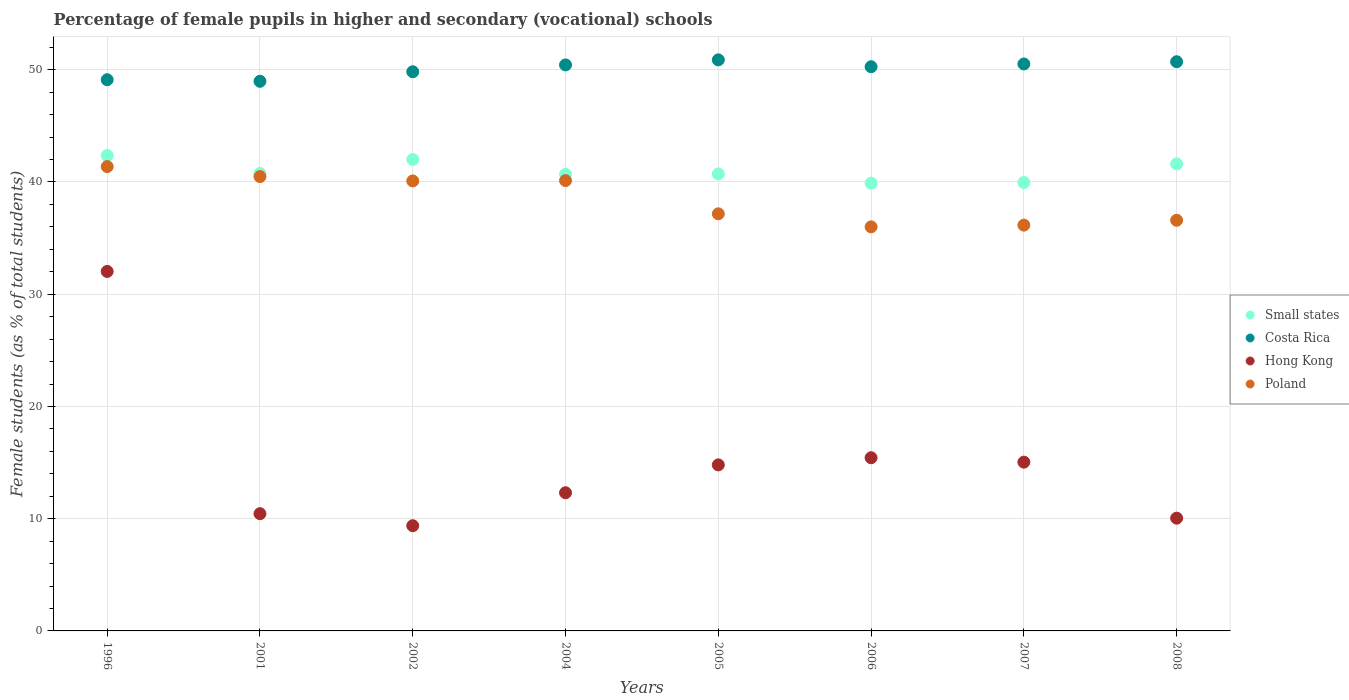Is the number of dotlines equal to the number of legend labels?
Give a very brief answer. Yes. What is the percentage of female pupils in higher and secondary schools in Poland in 2002?
Make the answer very short. 40.09. Across all years, what is the maximum percentage of female pupils in higher and secondary schools in Hong Kong?
Offer a terse response. 32.03. Across all years, what is the minimum percentage of female pupils in higher and secondary schools in Costa Rica?
Ensure brevity in your answer.  48.97. In which year was the percentage of female pupils in higher and secondary schools in Poland minimum?
Your answer should be compact. 2006. What is the total percentage of female pupils in higher and secondary schools in Small states in the graph?
Offer a very short reply. 327.98. What is the difference between the percentage of female pupils in higher and secondary schools in Small states in 2006 and that in 2007?
Keep it short and to the point. -0.06. What is the difference between the percentage of female pupils in higher and secondary schools in Hong Kong in 2006 and the percentage of female pupils in higher and secondary schools in Poland in 2002?
Provide a succinct answer. -24.66. What is the average percentage of female pupils in higher and secondary schools in Small states per year?
Your response must be concise. 41. In the year 2006, what is the difference between the percentage of female pupils in higher and secondary schools in Hong Kong and percentage of female pupils in higher and secondary schools in Costa Rica?
Provide a succinct answer. -34.84. In how many years, is the percentage of female pupils in higher and secondary schools in Poland greater than 42 %?
Your response must be concise. 0. What is the ratio of the percentage of female pupils in higher and secondary schools in Hong Kong in 2002 to that in 2005?
Keep it short and to the point. 0.63. Is the percentage of female pupils in higher and secondary schools in Poland in 2002 less than that in 2006?
Give a very brief answer. No. Is the difference between the percentage of female pupils in higher and secondary schools in Hong Kong in 2005 and 2008 greater than the difference between the percentage of female pupils in higher and secondary schools in Costa Rica in 2005 and 2008?
Make the answer very short. Yes. What is the difference between the highest and the second highest percentage of female pupils in higher and secondary schools in Small states?
Provide a short and direct response. 0.36. What is the difference between the highest and the lowest percentage of female pupils in higher and secondary schools in Small states?
Your answer should be very brief. 2.47. In how many years, is the percentage of female pupils in higher and secondary schools in Small states greater than the average percentage of female pupils in higher and secondary schools in Small states taken over all years?
Your answer should be very brief. 3. Is the percentage of female pupils in higher and secondary schools in Hong Kong strictly greater than the percentage of female pupils in higher and secondary schools in Poland over the years?
Offer a terse response. No. How many legend labels are there?
Offer a very short reply. 4. What is the title of the graph?
Provide a short and direct response. Percentage of female pupils in higher and secondary (vocational) schools. What is the label or title of the X-axis?
Provide a succinct answer. Years. What is the label or title of the Y-axis?
Keep it short and to the point. Female students (as % of total students). What is the Female students (as % of total students) in Small states in 1996?
Give a very brief answer. 42.36. What is the Female students (as % of total students) in Costa Rica in 1996?
Provide a short and direct response. 49.11. What is the Female students (as % of total students) in Hong Kong in 1996?
Offer a terse response. 32.03. What is the Female students (as % of total students) in Poland in 1996?
Your response must be concise. 41.37. What is the Female students (as % of total students) in Small states in 2001?
Give a very brief answer. 40.76. What is the Female students (as % of total students) of Costa Rica in 2001?
Make the answer very short. 48.97. What is the Female students (as % of total students) of Hong Kong in 2001?
Provide a short and direct response. 10.45. What is the Female students (as % of total students) in Poland in 2001?
Provide a succinct answer. 40.48. What is the Female students (as % of total students) in Small states in 2002?
Your response must be concise. 42. What is the Female students (as % of total students) of Costa Rica in 2002?
Your answer should be very brief. 49.82. What is the Female students (as % of total students) in Hong Kong in 2002?
Offer a very short reply. 9.37. What is the Female students (as % of total students) in Poland in 2002?
Provide a succinct answer. 40.09. What is the Female students (as % of total students) of Small states in 2004?
Ensure brevity in your answer.  40.68. What is the Female students (as % of total students) of Costa Rica in 2004?
Give a very brief answer. 50.43. What is the Female students (as % of total students) in Hong Kong in 2004?
Offer a terse response. 12.31. What is the Female students (as % of total students) of Poland in 2004?
Ensure brevity in your answer.  40.12. What is the Female students (as % of total students) in Small states in 2005?
Make the answer very short. 40.72. What is the Female students (as % of total students) in Costa Rica in 2005?
Offer a very short reply. 50.88. What is the Female students (as % of total students) in Hong Kong in 2005?
Your response must be concise. 14.79. What is the Female students (as % of total students) of Poland in 2005?
Offer a terse response. 37.16. What is the Female students (as % of total students) of Small states in 2006?
Give a very brief answer. 39.89. What is the Female students (as % of total students) of Costa Rica in 2006?
Your response must be concise. 50.27. What is the Female students (as % of total students) of Hong Kong in 2006?
Provide a succinct answer. 15.43. What is the Female students (as % of total students) in Poland in 2006?
Give a very brief answer. 36. What is the Female students (as % of total students) in Small states in 2007?
Provide a short and direct response. 39.95. What is the Female students (as % of total students) in Costa Rica in 2007?
Keep it short and to the point. 50.52. What is the Female students (as % of total students) in Hong Kong in 2007?
Keep it short and to the point. 15.04. What is the Female students (as % of total students) of Poland in 2007?
Provide a short and direct response. 36.15. What is the Female students (as % of total students) in Small states in 2008?
Provide a short and direct response. 41.61. What is the Female students (as % of total students) in Costa Rica in 2008?
Provide a succinct answer. 50.71. What is the Female students (as % of total students) of Hong Kong in 2008?
Make the answer very short. 10.05. What is the Female students (as % of total students) of Poland in 2008?
Give a very brief answer. 36.59. Across all years, what is the maximum Female students (as % of total students) of Small states?
Offer a terse response. 42.36. Across all years, what is the maximum Female students (as % of total students) of Costa Rica?
Ensure brevity in your answer.  50.88. Across all years, what is the maximum Female students (as % of total students) in Hong Kong?
Make the answer very short. 32.03. Across all years, what is the maximum Female students (as % of total students) in Poland?
Your answer should be compact. 41.37. Across all years, what is the minimum Female students (as % of total students) of Small states?
Give a very brief answer. 39.89. Across all years, what is the minimum Female students (as % of total students) in Costa Rica?
Provide a short and direct response. 48.97. Across all years, what is the minimum Female students (as % of total students) in Hong Kong?
Your answer should be compact. 9.37. Across all years, what is the minimum Female students (as % of total students) in Poland?
Your answer should be very brief. 36. What is the total Female students (as % of total students) of Small states in the graph?
Your response must be concise. 327.98. What is the total Female students (as % of total students) of Costa Rica in the graph?
Provide a short and direct response. 400.71. What is the total Female students (as % of total students) in Hong Kong in the graph?
Your answer should be very brief. 119.47. What is the total Female students (as % of total students) of Poland in the graph?
Provide a short and direct response. 307.98. What is the difference between the Female students (as % of total students) in Small states in 1996 and that in 2001?
Your answer should be compact. 1.6. What is the difference between the Female students (as % of total students) in Costa Rica in 1996 and that in 2001?
Your response must be concise. 0.14. What is the difference between the Female students (as % of total students) in Hong Kong in 1996 and that in 2001?
Make the answer very short. 21.58. What is the difference between the Female students (as % of total students) of Poland in 1996 and that in 2001?
Your answer should be very brief. 0.89. What is the difference between the Female students (as % of total students) of Small states in 1996 and that in 2002?
Your answer should be very brief. 0.36. What is the difference between the Female students (as % of total students) in Costa Rica in 1996 and that in 2002?
Give a very brief answer. -0.71. What is the difference between the Female students (as % of total students) in Hong Kong in 1996 and that in 2002?
Your answer should be very brief. 22.65. What is the difference between the Female students (as % of total students) in Poland in 1996 and that in 2002?
Offer a terse response. 1.28. What is the difference between the Female students (as % of total students) of Small states in 1996 and that in 2004?
Your answer should be compact. 1.68. What is the difference between the Female students (as % of total students) of Costa Rica in 1996 and that in 2004?
Your answer should be compact. -1.32. What is the difference between the Female students (as % of total students) in Hong Kong in 1996 and that in 2004?
Your answer should be very brief. 19.72. What is the difference between the Female students (as % of total students) in Poland in 1996 and that in 2004?
Your response must be concise. 1.25. What is the difference between the Female students (as % of total students) of Small states in 1996 and that in 2005?
Ensure brevity in your answer.  1.64. What is the difference between the Female students (as % of total students) in Costa Rica in 1996 and that in 2005?
Give a very brief answer. -1.77. What is the difference between the Female students (as % of total students) in Hong Kong in 1996 and that in 2005?
Your answer should be compact. 17.23. What is the difference between the Female students (as % of total students) in Poland in 1996 and that in 2005?
Your answer should be compact. 4.21. What is the difference between the Female students (as % of total students) of Small states in 1996 and that in 2006?
Provide a succinct answer. 2.47. What is the difference between the Female students (as % of total students) of Costa Rica in 1996 and that in 2006?
Offer a terse response. -1.16. What is the difference between the Female students (as % of total students) of Hong Kong in 1996 and that in 2006?
Keep it short and to the point. 16.6. What is the difference between the Female students (as % of total students) of Poland in 1996 and that in 2006?
Your response must be concise. 5.37. What is the difference between the Female students (as % of total students) in Small states in 1996 and that in 2007?
Keep it short and to the point. 2.41. What is the difference between the Female students (as % of total students) in Costa Rica in 1996 and that in 2007?
Give a very brief answer. -1.4. What is the difference between the Female students (as % of total students) in Hong Kong in 1996 and that in 2007?
Keep it short and to the point. 16.99. What is the difference between the Female students (as % of total students) of Poland in 1996 and that in 2007?
Provide a short and direct response. 5.22. What is the difference between the Female students (as % of total students) in Small states in 1996 and that in 2008?
Your response must be concise. 0.75. What is the difference between the Female students (as % of total students) in Costa Rica in 1996 and that in 2008?
Your response must be concise. -1.6. What is the difference between the Female students (as % of total students) in Hong Kong in 1996 and that in 2008?
Offer a very short reply. 21.98. What is the difference between the Female students (as % of total students) in Poland in 1996 and that in 2008?
Give a very brief answer. 4.78. What is the difference between the Female students (as % of total students) of Small states in 2001 and that in 2002?
Make the answer very short. -1.24. What is the difference between the Female students (as % of total students) of Costa Rica in 2001 and that in 2002?
Offer a very short reply. -0.85. What is the difference between the Female students (as % of total students) in Hong Kong in 2001 and that in 2002?
Provide a succinct answer. 1.07. What is the difference between the Female students (as % of total students) of Poland in 2001 and that in 2002?
Keep it short and to the point. 0.39. What is the difference between the Female students (as % of total students) of Small states in 2001 and that in 2004?
Offer a terse response. 0.08. What is the difference between the Female students (as % of total students) in Costa Rica in 2001 and that in 2004?
Provide a succinct answer. -1.46. What is the difference between the Female students (as % of total students) of Hong Kong in 2001 and that in 2004?
Provide a succinct answer. -1.86. What is the difference between the Female students (as % of total students) in Poland in 2001 and that in 2004?
Your response must be concise. 0.36. What is the difference between the Female students (as % of total students) in Small states in 2001 and that in 2005?
Make the answer very short. 0.05. What is the difference between the Female students (as % of total students) in Costa Rica in 2001 and that in 2005?
Provide a succinct answer. -1.91. What is the difference between the Female students (as % of total students) in Hong Kong in 2001 and that in 2005?
Your response must be concise. -4.35. What is the difference between the Female students (as % of total students) of Poland in 2001 and that in 2005?
Your answer should be compact. 3.32. What is the difference between the Female students (as % of total students) in Small states in 2001 and that in 2006?
Your response must be concise. 0.87. What is the difference between the Female students (as % of total students) of Costa Rica in 2001 and that in 2006?
Make the answer very short. -1.3. What is the difference between the Female students (as % of total students) of Hong Kong in 2001 and that in 2006?
Your response must be concise. -4.98. What is the difference between the Female students (as % of total students) of Poland in 2001 and that in 2006?
Ensure brevity in your answer.  4.48. What is the difference between the Female students (as % of total students) of Small states in 2001 and that in 2007?
Keep it short and to the point. 0.81. What is the difference between the Female students (as % of total students) in Costa Rica in 2001 and that in 2007?
Ensure brevity in your answer.  -1.55. What is the difference between the Female students (as % of total students) in Hong Kong in 2001 and that in 2007?
Your answer should be very brief. -4.59. What is the difference between the Female students (as % of total students) of Poland in 2001 and that in 2007?
Provide a short and direct response. 4.33. What is the difference between the Female students (as % of total students) in Small states in 2001 and that in 2008?
Your answer should be compact. -0.85. What is the difference between the Female students (as % of total students) of Costa Rica in 2001 and that in 2008?
Your answer should be very brief. -1.74. What is the difference between the Female students (as % of total students) in Hong Kong in 2001 and that in 2008?
Keep it short and to the point. 0.4. What is the difference between the Female students (as % of total students) in Poland in 2001 and that in 2008?
Keep it short and to the point. 3.89. What is the difference between the Female students (as % of total students) in Small states in 2002 and that in 2004?
Keep it short and to the point. 1.32. What is the difference between the Female students (as % of total students) in Costa Rica in 2002 and that in 2004?
Your response must be concise. -0.61. What is the difference between the Female students (as % of total students) of Hong Kong in 2002 and that in 2004?
Your answer should be compact. -2.94. What is the difference between the Female students (as % of total students) of Poland in 2002 and that in 2004?
Make the answer very short. -0.03. What is the difference between the Female students (as % of total students) in Small states in 2002 and that in 2005?
Give a very brief answer. 1.29. What is the difference between the Female students (as % of total students) in Costa Rica in 2002 and that in 2005?
Offer a terse response. -1.06. What is the difference between the Female students (as % of total students) of Hong Kong in 2002 and that in 2005?
Keep it short and to the point. -5.42. What is the difference between the Female students (as % of total students) of Poland in 2002 and that in 2005?
Provide a succinct answer. 2.93. What is the difference between the Female students (as % of total students) of Small states in 2002 and that in 2006?
Provide a succinct answer. 2.11. What is the difference between the Female students (as % of total students) in Costa Rica in 2002 and that in 2006?
Offer a terse response. -0.45. What is the difference between the Female students (as % of total students) of Hong Kong in 2002 and that in 2006?
Give a very brief answer. -6.06. What is the difference between the Female students (as % of total students) in Poland in 2002 and that in 2006?
Provide a succinct answer. 4.09. What is the difference between the Female students (as % of total students) in Small states in 2002 and that in 2007?
Offer a terse response. 2.05. What is the difference between the Female students (as % of total students) in Costa Rica in 2002 and that in 2007?
Offer a terse response. -0.69. What is the difference between the Female students (as % of total students) of Hong Kong in 2002 and that in 2007?
Your answer should be compact. -5.66. What is the difference between the Female students (as % of total students) in Poland in 2002 and that in 2007?
Your answer should be very brief. 3.94. What is the difference between the Female students (as % of total students) of Small states in 2002 and that in 2008?
Provide a succinct answer. 0.39. What is the difference between the Female students (as % of total students) in Costa Rica in 2002 and that in 2008?
Make the answer very short. -0.89. What is the difference between the Female students (as % of total students) in Hong Kong in 2002 and that in 2008?
Ensure brevity in your answer.  -0.67. What is the difference between the Female students (as % of total students) of Poland in 2002 and that in 2008?
Your response must be concise. 3.51. What is the difference between the Female students (as % of total students) of Small states in 2004 and that in 2005?
Your answer should be compact. -0.03. What is the difference between the Female students (as % of total students) of Costa Rica in 2004 and that in 2005?
Your response must be concise. -0.45. What is the difference between the Female students (as % of total students) of Hong Kong in 2004 and that in 2005?
Provide a succinct answer. -2.48. What is the difference between the Female students (as % of total students) of Poland in 2004 and that in 2005?
Make the answer very short. 2.96. What is the difference between the Female students (as % of total students) in Small states in 2004 and that in 2006?
Provide a short and direct response. 0.79. What is the difference between the Female students (as % of total students) in Costa Rica in 2004 and that in 2006?
Your answer should be compact. 0.16. What is the difference between the Female students (as % of total students) in Hong Kong in 2004 and that in 2006?
Provide a short and direct response. -3.12. What is the difference between the Female students (as % of total students) of Poland in 2004 and that in 2006?
Keep it short and to the point. 4.12. What is the difference between the Female students (as % of total students) of Small states in 2004 and that in 2007?
Give a very brief answer. 0.73. What is the difference between the Female students (as % of total students) in Costa Rica in 2004 and that in 2007?
Your answer should be compact. -0.09. What is the difference between the Female students (as % of total students) of Hong Kong in 2004 and that in 2007?
Offer a very short reply. -2.73. What is the difference between the Female students (as % of total students) in Poland in 2004 and that in 2007?
Make the answer very short. 3.97. What is the difference between the Female students (as % of total students) of Small states in 2004 and that in 2008?
Provide a short and direct response. -0.93. What is the difference between the Female students (as % of total students) of Costa Rica in 2004 and that in 2008?
Make the answer very short. -0.28. What is the difference between the Female students (as % of total students) of Hong Kong in 2004 and that in 2008?
Give a very brief answer. 2.26. What is the difference between the Female students (as % of total students) in Poland in 2004 and that in 2008?
Provide a succinct answer. 3.54. What is the difference between the Female students (as % of total students) in Small states in 2005 and that in 2006?
Offer a terse response. 0.82. What is the difference between the Female students (as % of total students) of Costa Rica in 2005 and that in 2006?
Offer a terse response. 0.61. What is the difference between the Female students (as % of total students) in Hong Kong in 2005 and that in 2006?
Offer a very short reply. -0.64. What is the difference between the Female students (as % of total students) in Poland in 2005 and that in 2006?
Provide a short and direct response. 1.16. What is the difference between the Female students (as % of total students) of Small states in 2005 and that in 2007?
Offer a terse response. 0.76. What is the difference between the Female students (as % of total students) in Costa Rica in 2005 and that in 2007?
Your answer should be very brief. 0.36. What is the difference between the Female students (as % of total students) in Hong Kong in 2005 and that in 2007?
Provide a succinct answer. -0.24. What is the difference between the Female students (as % of total students) in Poland in 2005 and that in 2007?
Provide a succinct answer. 1.01. What is the difference between the Female students (as % of total students) of Small states in 2005 and that in 2008?
Make the answer very short. -0.89. What is the difference between the Female students (as % of total students) in Costa Rica in 2005 and that in 2008?
Make the answer very short. 0.17. What is the difference between the Female students (as % of total students) of Hong Kong in 2005 and that in 2008?
Your answer should be very brief. 4.75. What is the difference between the Female students (as % of total students) of Poland in 2005 and that in 2008?
Offer a very short reply. 0.57. What is the difference between the Female students (as % of total students) in Small states in 2006 and that in 2007?
Offer a very short reply. -0.06. What is the difference between the Female students (as % of total students) of Costa Rica in 2006 and that in 2007?
Give a very brief answer. -0.25. What is the difference between the Female students (as % of total students) of Hong Kong in 2006 and that in 2007?
Offer a very short reply. 0.39. What is the difference between the Female students (as % of total students) of Poland in 2006 and that in 2007?
Offer a terse response. -0.15. What is the difference between the Female students (as % of total students) of Small states in 2006 and that in 2008?
Give a very brief answer. -1.72. What is the difference between the Female students (as % of total students) of Costa Rica in 2006 and that in 2008?
Your answer should be compact. -0.44. What is the difference between the Female students (as % of total students) in Hong Kong in 2006 and that in 2008?
Provide a short and direct response. 5.38. What is the difference between the Female students (as % of total students) in Poland in 2006 and that in 2008?
Offer a terse response. -0.59. What is the difference between the Female students (as % of total students) of Small states in 2007 and that in 2008?
Give a very brief answer. -1.66. What is the difference between the Female students (as % of total students) in Costa Rica in 2007 and that in 2008?
Ensure brevity in your answer.  -0.2. What is the difference between the Female students (as % of total students) of Hong Kong in 2007 and that in 2008?
Offer a terse response. 4.99. What is the difference between the Female students (as % of total students) of Poland in 2007 and that in 2008?
Offer a very short reply. -0.43. What is the difference between the Female students (as % of total students) in Small states in 1996 and the Female students (as % of total students) in Costa Rica in 2001?
Your answer should be very brief. -6.61. What is the difference between the Female students (as % of total students) in Small states in 1996 and the Female students (as % of total students) in Hong Kong in 2001?
Ensure brevity in your answer.  31.91. What is the difference between the Female students (as % of total students) in Small states in 1996 and the Female students (as % of total students) in Poland in 2001?
Keep it short and to the point. 1.88. What is the difference between the Female students (as % of total students) in Costa Rica in 1996 and the Female students (as % of total students) in Hong Kong in 2001?
Provide a short and direct response. 38.67. What is the difference between the Female students (as % of total students) in Costa Rica in 1996 and the Female students (as % of total students) in Poland in 2001?
Offer a terse response. 8.63. What is the difference between the Female students (as % of total students) in Hong Kong in 1996 and the Female students (as % of total students) in Poland in 2001?
Your response must be concise. -8.45. What is the difference between the Female students (as % of total students) in Small states in 1996 and the Female students (as % of total students) in Costa Rica in 2002?
Offer a very short reply. -7.46. What is the difference between the Female students (as % of total students) of Small states in 1996 and the Female students (as % of total students) of Hong Kong in 2002?
Provide a succinct answer. 32.99. What is the difference between the Female students (as % of total students) of Small states in 1996 and the Female students (as % of total students) of Poland in 2002?
Your answer should be very brief. 2.27. What is the difference between the Female students (as % of total students) in Costa Rica in 1996 and the Female students (as % of total students) in Hong Kong in 2002?
Make the answer very short. 39.74. What is the difference between the Female students (as % of total students) of Costa Rica in 1996 and the Female students (as % of total students) of Poland in 2002?
Make the answer very short. 9.02. What is the difference between the Female students (as % of total students) of Hong Kong in 1996 and the Female students (as % of total students) of Poland in 2002?
Your response must be concise. -8.07. What is the difference between the Female students (as % of total students) in Small states in 1996 and the Female students (as % of total students) in Costa Rica in 2004?
Give a very brief answer. -8.07. What is the difference between the Female students (as % of total students) in Small states in 1996 and the Female students (as % of total students) in Hong Kong in 2004?
Offer a terse response. 30.05. What is the difference between the Female students (as % of total students) in Small states in 1996 and the Female students (as % of total students) in Poland in 2004?
Provide a succinct answer. 2.24. What is the difference between the Female students (as % of total students) in Costa Rica in 1996 and the Female students (as % of total students) in Hong Kong in 2004?
Your response must be concise. 36.8. What is the difference between the Female students (as % of total students) in Costa Rica in 1996 and the Female students (as % of total students) in Poland in 2004?
Your response must be concise. 8.99. What is the difference between the Female students (as % of total students) of Hong Kong in 1996 and the Female students (as % of total students) of Poland in 2004?
Offer a terse response. -8.1. What is the difference between the Female students (as % of total students) of Small states in 1996 and the Female students (as % of total students) of Costa Rica in 2005?
Make the answer very short. -8.52. What is the difference between the Female students (as % of total students) of Small states in 1996 and the Female students (as % of total students) of Hong Kong in 2005?
Offer a very short reply. 27.57. What is the difference between the Female students (as % of total students) in Small states in 1996 and the Female students (as % of total students) in Poland in 2005?
Ensure brevity in your answer.  5.2. What is the difference between the Female students (as % of total students) of Costa Rica in 1996 and the Female students (as % of total students) of Hong Kong in 2005?
Your answer should be very brief. 34.32. What is the difference between the Female students (as % of total students) of Costa Rica in 1996 and the Female students (as % of total students) of Poland in 2005?
Ensure brevity in your answer.  11.95. What is the difference between the Female students (as % of total students) in Hong Kong in 1996 and the Female students (as % of total students) in Poland in 2005?
Your response must be concise. -5.13. What is the difference between the Female students (as % of total students) in Small states in 1996 and the Female students (as % of total students) in Costa Rica in 2006?
Your answer should be very brief. -7.91. What is the difference between the Female students (as % of total students) of Small states in 1996 and the Female students (as % of total students) of Hong Kong in 2006?
Your answer should be compact. 26.93. What is the difference between the Female students (as % of total students) of Small states in 1996 and the Female students (as % of total students) of Poland in 2006?
Your answer should be very brief. 6.36. What is the difference between the Female students (as % of total students) of Costa Rica in 1996 and the Female students (as % of total students) of Hong Kong in 2006?
Offer a very short reply. 33.68. What is the difference between the Female students (as % of total students) in Costa Rica in 1996 and the Female students (as % of total students) in Poland in 2006?
Make the answer very short. 13.11. What is the difference between the Female students (as % of total students) of Hong Kong in 1996 and the Female students (as % of total students) of Poland in 2006?
Offer a very short reply. -3.97. What is the difference between the Female students (as % of total students) of Small states in 1996 and the Female students (as % of total students) of Costa Rica in 2007?
Provide a short and direct response. -8.16. What is the difference between the Female students (as % of total students) of Small states in 1996 and the Female students (as % of total students) of Hong Kong in 2007?
Provide a succinct answer. 27.32. What is the difference between the Female students (as % of total students) in Small states in 1996 and the Female students (as % of total students) in Poland in 2007?
Your answer should be very brief. 6.2. What is the difference between the Female students (as % of total students) in Costa Rica in 1996 and the Female students (as % of total students) in Hong Kong in 2007?
Offer a terse response. 34.07. What is the difference between the Female students (as % of total students) of Costa Rica in 1996 and the Female students (as % of total students) of Poland in 2007?
Offer a very short reply. 12.96. What is the difference between the Female students (as % of total students) in Hong Kong in 1996 and the Female students (as % of total students) in Poland in 2007?
Keep it short and to the point. -4.13. What is the difference between the Female students (as % of total students) of Small states in 1996 and the Female students (as % of total students) of Costa Rica in 2008?
Keep it short and to the point. -8.35. What is the difference between the Female students (as % of total students) in Small states in 1996 and the Female students (as % of total students) in Hong Kong in 2008?
Provide a succinct answer. 32.31. What is the difference between the Female students (as % of total students) of Small states in 1996 and the Female students (as % of total students) of Poland in 2008?
Your answer should be very brief. 5.77. What is the difference between the Female students (as % of total students) of Costa Rica in 1996 and the Female students (as % of total students) of Hong Kong in 2008?
Provide a short and direct response. 39.06. What is the difference between the Female students (as % of total students) of Costa Rica in 1996 and the Female students (as % of total students) of Poland in 2008?
Offer a very short reply. 12.52. What is the difference between the Female students (as % of total students) in Hong Kong in 1996 and the Female students (as % of total students) in Poland in 2008?
Keep it short and to the point. -4.56. What is the difference between the Female students (as % of total students) in Small states in 2001 and the Female students (as % of total students) in Costa Rica in 2002?
Ensure brevity in your answer.  -9.06. What is the difference between the Female students (as % of total students) in Small states in 2001 and the Female students (as % of total students) in Hong Kong in 2002?
Keep it short and to the point. 31.39. What is the difference between the Female students (as % of total students) in Small states in 2001 and the Female students (as % of total students) in Poland in 2002?
Ensure brevity in your answer.  0.67. What is the difference between the Female students (as % of total students) in Costa Rica in 2001 and the Female students (as % of total students) in Hong Kong in 2002?
Your answer should be compact. 39.6. What is the difference between the Female students (as % of total students) in Costa Rica in 2001 and the Female students (as % of total students) in Poland in 2002?
Offer a terse response. 8.88. What is the difference between the Female students (as % of total students) of Hong Kong in 2001 and the Female students (as % of total students) of Poland in 2002?
Provide a succinct answer. -29.65. What is the difference between the Female students (as % of total students) in Small states in 2001 and the Female students (as % of total students) in Costa Rica in 2004?
Keep it short and to the point. -9.67. What is the difference between the Female students (as % of total students) of Small states in 2001 and the Female students (as % of total students) of Hong Kong in 2004?
Your answer should be compact. 28.45. What is the difference between the Female students (as % of total students) of Small states in 2001 and the Female students (as % of total students) of Poland in 2004?
Provide a succinct answer. 0.64. What is the difference between the Female students (as % of total students) of Costa Rica in 2001 and the Female students (as % of total students) of Hong Kong in 2004?
Offer a very short reply. 36.66. What is the difference between the Female students (as % of total students) of Costa Rica in 2001 and the Female students (as % of total students) of Poland in 2004?
Provide a succinct answer. 8.85. What is the difference between the Female students (as % of total students) in Hong Kong in 2001 and the Female students (as % of total students) in Poland in 2004?
Your answer should be very brief. -29.68. What is the difference between the Female students (as % of total students) in Small states in 2001 and the Female students (as % of total students) in Costa Rica in 2005?
Your answer should be very brief. -10.12. What is the difference between the Female students (as % of total students) in Small states in 2001 and the Female students (as % of total students) in Hong Kong in 2005?
Ensure brevity in your answer.  25.97. What is the difference between the Female students (as % of total students) in Small states in 2001 and the Female students (as % of total students) in Poland in 2005?
Provide a succinct answer. 3.6. What is the difference between the Female students (as % of total students) in Costa Rica in 2001 and the Female students (as % of total students) in Hong Kong in 2005?
Your answer should be compact. 34.18. What is the difference between the Female students (as % of total students) of Costa Rica in 2001 and the Female students (as % of total students) of Poland in 2005?
Ensure brevity in your answer.  11.81. What is the difference between the Female students (as % of total students) of Hong Kong in 2001 and the Female students (as % of total students) of Poland in 2005?
Provide a short and direct response. -26.72. What is the difference between the Female students (as % of total students) in Small states in 2001 and the Female students (as % of total students) in Costa Rica in 2006?
Offer a terse response. -9.51. What is the difference between the Female students (as % of total students) of Small states in 2001 and the Female students (as % of total students) of Hong Kong in 2006?
Your response must be concise. 25.33. What is the difference between the Female students (as % of total students) in Small states in 2001 and the Female students (as % of total students) in Poland in 2006?
Ensure brevity in your answer.  4.76. What is the difference between the Female students (as % of total students) in Costa Rica in 2001 and the Female students (as % of total students) in Hong Kong in 2006?
Ensure brevity in your answer.  33.54. What is the difference between the Female students (as % of total students) in Costa Rica in 2001 and the Female students (as % of total students) in Poland in 2006?
Keep it short and to the point. 12.97. What is the difference between the Female students (as % of total students) of Hong Kong in 2001 and the Female students (as % of total students) of Poland in 2006?
Your answer should be compact. -25.56. What is the difference between the Female students (as % of total students) of Small states in 2001 and the Female students (as % of total students) of Costa Rica in 2007?
Offer a very short reply. -9.75. What is the difference between the Female students (as % of total students) in Small states in 2001 and the Female students (as % of total students) in Hong Kong in 2007?
Keep it short and to the point. 25.72. What is the difference between the Female students (as % of total students) of Small states in 2001 and the Female students (as % of total students) of Poland in 2007?
Offer a very short reply. 4.61. What is the difference between the Female students (as % of total students) in Costa Rica in 2001 and the Female students (as % of total students) in Hong Kong in 2007?
Your response must be concise. 33.93. What is the difference between the Female students (as % of total students) of Costa Rica in 2001 and the Female students (as % of total students) of Poland in 2007?
Offer a very short reply. 12.81. What is the difference between the Female students (as % of total students) in Hong Kong in 2001 and the Female students (as % of total students) in Poland in 2007?
Offer a very short reply. -25.71. What is the difference between the Female students (as % of total students) of Small states in 2001 and the Female students (as % of total students) of Costa Rica in 2008?
Provide a short and direct response. -9.95. What is the difference between the Female students (as % of total students) in Small states in 2001 and the Female students (as % of total students) in Hong Kong in 2008?
Your answer should be very brief. 30.71. What is the difference between the Female students (as % of total students) in Small states in 2001 and the Female students (as % of total students) in Poland in 2008?
Provide a succinct answer. 4.17. What is the difference between the Female students (as % of total students) in Costa Rica in 2001 and the Female students (as % of total students) in Hong Kong in 2008?
Offer a terse response. 38.92. What is the difference between the Female students (as % of total students) in Costa Rica in 2001 and the Female students (as % of total students) in Poland in 2008?
Make the answer very short. 12.38. What is the difference between the Female students (as % of total students) of Hong Kong in 2001 and the Female students (as % of total students) of Poland in 2008?
Your answer should be compact. -26.14. What is the difference between the Female students (as % of total students) of Small states in 2002 and the Female students (as % of total students) of Costa Rica in 2004?
Your answer should be compact. -8.43. What is the difference between the Female students (as % of total students) of Small states in 2002 and the Female students (as % of total students) of Hong Kong in 2004?
Provide a short and direct response. 29.69. What is the difference between the Female students (as % of total students) in Small states in 2002 and the Female students (as % of total students) in Poland in 2004?
Your answer should be compact. 1.88. What is the difference between the Female students (as % of total students) of Costa Rica in 2002 and the Female students (as % of total students) of Hong Kong in 2004?
Give a very brief answer. 37.51. What is the difference between the Female students (as % of total students) of Costa Rica in 2002 and the Female students (as % of total students) of Poland in 2004?
Your answer should be very brief. 9.7. What is the difference between the Female students (as % of total students) in Hong Kong in 2002 and the Female students (as % of total students) in Poland in 2004?
Offer a terse response. -30.75. What is the difference between the Female students (as % of total students) in Small states in 2002 and the Female students (as % of total students) in Costa Rica in 2005?
Offer a terse response. -8.88. What is the difference between the Female students (as % of total students) of Small states in 2002 and the Female students (as % of total students) of Hong Kong in 2005?
Offer a terse response. 27.21. What is the difference between the Female students (as % of total students) of Small states in 2002 and the Female students (as % of total students) of Poland in 2005?
Your response must be concise. 4.84. What is the difference between the Female students (as % of total students) in Costa Rica in 2002 and the Female students (as % of total students) in Hong Kong in 2005?
Your response must be concise. 35.03. What is the difference between the Female students (as % of total students) in Costa Rica in 2002 and the Female students (as % of total students) in Poland in 2005?
Your answer should be compact. 12.66. What is the difference between the Female students (as % of total students) of Hong Kong in 2002 and the Female students (as % of total students) of Poland in 2005?
Give a very brief answer. -27.79. What is the difference between the Female students (as % of total students) of Small states in 2002 and the Female students (as % of total students) of Costa Rica in 2006?
Your answer should be very brief. -8.27. What is the difference between the Female students (as % of total students) in Small states in 2002 and the Female students (as % of total students) in Hong Kong in 2006?
Provide a short and direct response. 26.57. What is the difference between the Female students (as % of total students) of Small states in 2002 and the Female students (as % of total students) of Poland in 2006?
Offer a very short reply. 6. What is the difference between the Female students (as % of total students) in Costa Rica in 2002 and the Female students (as % of total students) in Hong Kong in 2006?
Ensure brevity in your answer.  34.39. What is the difference between the Female students (as % of total students) in Costa Rica in 2002 and the Female students (as % of total students) in Poland in 2006?
Ensure brevity in your answer.  13.82. What is the difference between the Female students (as % of total students) in Hong Kong in 2002 and the Female students (as % of total students) in Poland in 2006?
Make the answer very short. -26.63. What is the difference between the Female students (as % of total students) of Small states in 2002 and the Female students (as % of total students) of Costa Rica in 2007?
Provide a short and direct response. -8.51. What is the difference between the Female students (as % of total students) in Small states in 2002 and the Female students (as % of total students) in Hong Kong in 2007?
Ensure brevity in your answer.  26.96. What is the difference between the Female students (as % of total students) in Small states in 2002 and the Female students (as % of total students) in Poland in 2007?
Keep it short and to the point. 5.85. What is the difference between the Female students (as % of total students) in Costa Rica in 2002 and the Female students (as % of total students) in Hong Kong in 2007?
Give a very brief answer. 34.78. What is the difference between the Female students (as % of total students) in Costa Rica in 2002 and the Female students (as % of total students) in Poland in 2007?
Offer a terse response. 13.67. What is the difference between the Female students (as % of total students) in Hong Kong in 2002 and the Female students (as % of total students) in Poland in 2007?
Your answer should be very brief. -26.78. What is the difference between the Female students (as % of total students) in Small states in 2002 and the Female students (as % of total students) in Costa Rica in 2008?
Offer a terse response. -8.71. What is the difference between the Female students (as % of total students) of Small states in 2002 and the Female students (as % of total students) of Hong Kong in 2008?
Keep it short and to the point. 31.96. What is the difference between the Female students (as % of total students) in Small states in 2002 and the Female students (as % of total students) in Poland in 2008?
Give a very brief answer. 5.41. What is the difference between the Female students (as % of total students) in Costa Rica in 2002 and the Female students (as % of total students) in Hong Kong in 2008?
Your answer should be very brief. 39.77. What is the difference between the Female students (as % of total students) in Costa Rica in 2002 and the Female students (as % of total students) in Poland in 2008?
Offer a terse response. 13.23. What is the difference between the Female students (as % of total students) of Hong Kong in 2002 and the Female students (as % of total students) of Poland in 2008?
Your answer should be compact. -27.21. What is the difference between the Female students (as % of total students) in Small states in 2004 and the Female students (as % of total students) in Costa Rica in 2005?
Ensure brevity in your answer.  -10.2. What is the difference between the Female students (as % of total students) in Small states in 2004 and the Female students (as % of total students) in Hong Kong in 2005?
Keep it short and to the point. 25.89. What is the difference between the Female students (as % of total students) in Small states in 2004 and the Female students (as % of total students) in Poland in 2005?
Give a very brief answer. 3.52. What is the difference between the Female students (as % of total students) of Costa Rica in 2004 and the Female students (as % of total students) of Hong Kong in 2005?
Keep it short and to the point. 35.64. What is the difference between the Female students (as % of total students) of Costa Rica in 2004 and the Female students (as % of total students) of Poland in 2005?
Ensure brevity in your answer.  13.27. What is the difference between the Female students (as % of total students) in Hong Kong in 2004 and the Female students (as % of total students) in Poland in 2005?
Your answer should be very brief. -24.85. What is the difference between the Female students (as % of total students) of Small states in 2004 and the Female students (as % of total students) of Costa Rica in 2006?
Keep it short and to the point. -9.59. What is the difference between the Female students (as % of total students) in Small states in 2004 and the Female students (as % of total students) in Hong Kong in 2006?
Provide a short and direct response. 25.25. What is the difference between the Female students (as % of total students) of Small states in 2004 and the Female students (as % of total students) of Poland in 2006?
Make the answer very short. 4.68. What is the difference between the Female students (as % of total students) of Costa Rica in 2004 and the Female students (as % of total students) of Hong Kong in 2006?
Ensure brevity in your answer.  35. What is the difference between the Female students (as % of total students) of Costa Rica in 2004 and the Female students (as % of total students) of Poland in 2006?
Provide a succinct answer. 14.43. What is the difference between the Female students (as % of total students) of Hong Kong in 2004 and the Female students (as % of total students) of Poland in 2006?
Your response must be concise. -23.69. What is the difference between the Female students (as % of total students) of Small states in 2004 and the Female students (as % of total students) of Costa Rica in 2007?
Your response must be concise. -9.83. What is the difference between the Female students (as % of total students) in Small states in 2004 and the Female students (as % of total students) in Hong Kong in 2007?
Offer a terse response. 25.65. What is the difference between the Female students (as % of total students) in Small states in 2004 and the Female students (as % of total students) in Poland in 2007?
Your answer should be very brief. 4.53. What is the difference between the Female students (as % of total students) in Costa Rica in 2004 and the Female students (as % of total students) in Hong Kong in 2007?
Make the answer very short. 35.39. What is the difference between the Female students (as % of total students) in Costa Rica in 2004 and the Female students (as % of total students) in Poland in 2007?
Your answer should be compact. 14.28. What is the difference between the Female students (as % of total students) of Hong Kong in 2004 and the Female students (as % of total students) of Poland in 2007?
Keep it short and to the point. -23.84. What is the difference between the Female students (as % of total students) of Small states in 2004 and the Female students (as % of total students) of Costa Rica in 2008?
Provide a short and direct response. -10.03. What is the difference between the Female students (as % of total students) of Small states in 2004 and the Female students (as % of total students) of Hong Kong in 2008?
Give a very brief answer. 30.64. What is the difference between the Female students (as % of total students) of Small states in 2004 and the Female students (as % of total students) of Poland in 2008?
Your answer should be compact. 4.1. What is the difference between the Female students (as % of total students) in Costa Rica in 2004 and the Female students (as % of total students) in Hong Kong in 2008?
Your answer should be compact. 40.38. What is the difference between the Female students (as % of total students) of Costa Rica in 2004 and the Female students (as % of total students) of Poland in 2008?
Offer a terse response. 13.84. What is the difference between the Female students (as % of total students) in Hong Kong in 2004 and the Female students (as % of total students) in Poland in 2008?
Your answer should be compact. -24.28. What is the difference between the Female students (as % of total students) of Small states in 2005 and the Female students (as % of total students) of Costa Rica in 2006?
Your answer should be compact. -9.55. What is the difference between the Female students (as % of total students) in Small states in 2005 and the Female students (as % of total students) in Hong Kong in 2006?
Provide a succinct answer. 25.28. What is the difference between the Female students (as % of total students) in Small states in 2005 and the Female students (as % of total students) in Poland in 2006?
Ensure brevity in your answer.  4.71. What is the difference between the Female students (as % of total students) of Costa Rica in 2005 and the Female students (as % of total students) of Hong Kong in 2006?
Provide a succinct answer. 35.45. What is the difference between the Female students (as % of total students) in Costa Rica in 2005 and the Female students (as % of total students) in Poland in 2006?
Offer a very short reply. 14.88. What is the difference between the Female students (as % of total students) of Hong Kong in 2005 and the Female students (as % of total students) of Poland in 2006?
Your response must be concise. -21.21. What is the difference between the Female students (as % of total students) in Small states in 2005 and the Female students (as % of total students) in Costa Rica in 2007?
Keep it short and to the point. -9.8. What is the difference between the Female students (as % of total students) in Small states in 2005 and the Female students (as % of total students) in Hong Kong in 2007?
Provide a short and direct response. 25.68. What is the difference between the Female students (as % of total students) in Small states in 2005 and the Female students (as % of total students) in Poland in 2007?
Provide a short and direct response. 4.56. What is the difference between the Female students (as % of total students) in Costa Rica in 2005 and the Female students (as % of total students) in Hong Kong in 2007?
Provide a succinct answer. 35.84. What is the difference between the Female students (as % of total students) in Costa Rica in 2005 and the Female students (as % of total students) in Poland in 2007?
Provide a succinct answer. 14.72. What is the difference between the Female students (as % of total students) in Hong Kong in 2005 and the Female students (as % of total students) in Poland in 2007?
Your answer should be compact. -21.36. What is the difference between the Female students (as % of total students) in Small states in 2005 and the Female students (as % of total students) in Costa Rica in 2008?
Offer a terse response. -10. What is the difference between the Female students (as % of total students) in Small states in 2005 and the Female students (as % of total students) in Hong Kong in 2008?
Provide a short and direct response. 30.67. What is the difference between the Female students (as % of total students) of Small states in 2005 and the Female students (as % of total students) of Poland in 2008?
Your answer should be compact. 4.13. What is the difference between the Female students (as % of total students) of Costa Rica in 2005 and the Female students (as % of total students) of Hong Kong in 2008?
Offer a terse response. 40.83. What is the difference between the Female students (as % of total students) in Costa Rica in 2005 and the Female students (as % of total students) in Poland in 2008?
Ensure brevity in your answer.  14.29. What is the difference between the Female students (as % of total students) of Hong Kong in 2005 and the Female students (as % of total students) of Poland in 2008?
Ensure brevity in your answer.  -21.79. What is the difference between the Female students (as % of total students) in Small states in 2006 and the Female students (as % of total students) in Costa Rica in 2007?
Provide a short and direct response. -10.62. What is the difference between the Female students (as % of total students) of Small states in 2006 and the Female students (as % of total students) of Hong Kong in 2007?
Keep it short and to the point. 24.86. What is the difference between the Female students (as % of total students) in Small states in 2006 and the Female students (as % of total students) in Poland in 2007?
Make the answer very short. 3.74. What is the difference between the Female students (as % of total students) of Costa Rica in 2006 and the Female students (as % of total students) of Hong Kong in 2007?
Your answer should be very brief. 35.23. What is the difference between the Female students (as % of total students) of Costa Rica in 2006 and the Female students (as % of total students) of Poland in 2007?
Make the answer very short. 14.11. What is the difference between the Female students (as % of total students) in Hong Kong in 2006 and the Female students (as % of total students) in Poland in 2007?
Provide a succinct answer. -20.72. What is the difference between the Female students (as % of total students) of Small states in 2006 and the Female students (as % of total students) of Costa Rica in 2008?
Provide a succinct answer. -10.82. What is the difference between the Female students (as % of total students) of Small states in 2006 and the Female students (as % of total students) of Hong Kong in 2008?
Your response must be concise. 29.85. What is the difference between the Female students (as % of total students) of Small states in 2006 and the Female students (as % of total students) of Poland in 2008?
Provide a short and direct response. 3.3. What is the difference between the Female students (as % of total students) of Costa Rica in 2006 and the Female students (as % of total students) of Hong Kong in 2008?
Provide a short and direct response. 40.22. What is the difference between the Female students (as % of total students) of Costa Rica in 2006 and the Female students (as % of total students) of Poland in 2008?
Provide a succinct answer. 13.68. What is the difference between the Female students (as % of total students) in Hong Kong in 2006 and the Female students (as % of total students) in Poland in 2008?
Your response must be concise. -21.16. What is the difference between the Female students (as % of total students) of Small states in 2007 and the Female students (as % of total students) of Costa Rica in 2008?
Offer a very short reply. -10.76. What is the difference between the Female students (as % of total students) in Small states in 2007 and the Female students (as % of total students) in Hong Kong in 2008?
Provide a short and direct response. 29.91. What is the difference between the Female students (as % of total students) in Small states in 2007 and the Female students (as % of total students) in Poland in 2008?
Give a very brief answer. 3.36. What is the difference between the Female students (as % of total students) in Costa Rica in 2007 and the Female students (as % of total students) in Hong Kong in 2008?
Give a very brief answer. 40.47. What is the difference between the Female students (as % of total students) in Costa Rica in 2007 and the Female students (as % of total students) in Poland in 2008?
Ensure brevity in your answer.  13.93. What is the difference between the Female students (as % of total students) in Hong Kong in 2007 and the Female students (as % of total students) in Poland in 2008?
Offer a terse response. -21.55. What is the average Female students (as % of total students) in Small states per year?
Offer a very short reply. 41. What is the average Female students (as % of total students) in Costa Rica per year?
Your answer should be very brief. 50.09. What is the average Female students (as % of total students) of Hong Kong per year?
Your response must be concise. 14.93. What is the average Female students (as % of total students) of Poland per year?
Keep it short and to the point. 38.5. In the year 1996, what is the difference between the Female students (as % of total students) in Small states and Female students (as % of total students) in Costa Rica?
Provide a succinct answer. -6.75. In the year 1996, what is the difference between the Female students (as % of total students) in Small states and Female students (as % of total students) in Hong Kong?
Provide a short and direct response. 10.33. In the year 1996, what is the difference between the Female students (as % of total students) of Costa Rica and Female students (as % of total students) of Hong Kong?
Provide a succinct answer. 17.08. In the year 1996, what is the difference between the Female students (as % of total students) in Costa Rica and Female students (as % of total students) in Poland?
Ensure brevity in your answer.  7.74. In the year 1996, what is the difference between the Female students (as % of total students) in Hong Kong and Female students (as % of total students) in Poland?
Your answer should be compact. -9.34. In the year 2001, what is the difference between the Female students (as % of total students) in Small states and Female students (as % of total students) in Costa Rica?
Ensure brevity in your answer.  -8.21. In the year 2001, what is the difference between the Female students (as % of total students) in Small states and Female students (as % of total students) in Hong Kong?
Your answer should be compact. 30.31. In the year 2001, what is the difference between the Female students (as % of total students) in Small states and Female students (as % of total students) in Poland?
Your answer should be very brief. 0.28. In the year 2001, what is the difference between the Female students (as % of total students) in Costa Rica and Female students (as % of total students) in Hong Kong?
Offer a terse response. 38.52. In the year 2001, what is the difference between the Female students (as % of total students) in Costa Rica and Female students (as % of total students) in Poland?
Give a very brief answer. 8.49. In the year 2001, what is the difference between the Female students (as % of total students) in Hong Kong and Female students (as % of total students) in Poland?
Your answer should be compact. -30.04. In the year 2002, what is the difference between the Female students (as % of total students) in Small states and Female students (as % of total students) in Costa Rica?
Offer a terse response. -7.82. In the year 2002, what is the difference between the Female students (as % of total students) of Small states and Female students (as % of total students) of Hong Kong?
Ensure brevity in your answer.  32.63. In the year 2002, what is the difference between the Female students (as % of total students) of Small states and Female students (as % of total students) of Poland?
Make the answer very short. 1.91. In the year 2002, what is the difference between the Female students (as % of total students) of Costa Rica and Female students (as % of total students) of Hong Kong?
Offer a very short reply. 40.45. In the year 2002, what is the difference between the Female students (as % of total students) in Costa Rica and Female students (as % of total students) in Poland?
Provide a short and direct response. 9.73. In the year 2002, what is the difference between the Female students (as % of total students) of Hong Kong and Female students (as % of total students) of Poland?
Your answer should be compact. -30.72. In the year 2004, what is the difference between the Female students (as % of total students) in Small states and Female students (as % of total students) in Costa Rica?
Provide a short and direct response. -9.75. In the year 2004, what is the difference between the Female students (as % of total students) in Small states and Female students (as % of total students) in Hong Kong?
Your response must be concise. 28.37. In the year 2004, what is the difference between the Female students (as % of total students) of Small states and Female students (as % of total students) of Poland?
Your response must be concise. 0.56. In the year 2004, what is the difference between the Female students (as % of total students) in Costa Rica and Female students (as % of total students) in Hong Kong?
Keep it short and to the point. 38.12. In the year 2004, what is the difference between the Female students (as % of total students) of Costa Rica and Female students (as % of total students) of Poland?
Offer a terse response. 10.31. In the year 2004, what is the difference between the Female students (as % of total students) of Hong Kong and Female students (as % of total students) of Poland?
Give a very brief answer. -27.81. In the year 2005, what is the difference between the Female students (as % of total students) of Small states and Female students (as % of total students) of Costa Rica?
Ensure brevity in your answer.  -10.16. In the year 2005, what is the difference between the Female students (as % of total students) of Small states and Female students (as % of total students) of Hong Kong?
Your response must be concise. 25.92. In the year 2005, what is the difference between the Female students (as % of total students) in Small states and Female students (as % of total students) in Poland?
Ensure brevity in your answer.  3.55. In the year 2005, what is the difference between the Female students (as % of total students) in Costa Rica and Female students (as % of total students) in Hong Kong?
Keep it short and to the point. 36.09. In the year 2005, what is the difference between the Female students (as % of total students) of Costa Rica and Female students (as % of total students) of Poland?
Your answer should be very brief. 13.72. In the year 2005, what is the difference between the Female students (as % of total students) of Hong Kong and Female students (as % of total students) of Poland?
Ensure brevity in your answer.  -22.37. In the year 2006, what is the difference between the Female students (as % of total students) of Small states and Female students (as % of total students) of Costa Rica?
Provide a short and direct response. -10.38. In the year 2006, what is the difference between the Female students (as % of total students) in Small states and Female students (as % of total students) in Hong Kong?
Offer a very short reply. 24.46. In the year 2006, what is the difference between the Female students (as % of total students) in Small states and Female students (as % of total students) in Poland?
Your response must be concise. 3.89. In the year 2006, what is the difference between the Female students (as % of total students) of Costa Rica and Female students (as % of total students) of Hong Kong?
Your answer should be compact. 34.84. In the year 2006, what is the difference between the Female students (as % of total students) of Costa Rica and Female students (as % of total students) of Poland?
Offer a very short reply. 14.27. In the year 2006, what is the difference between the Female students (as % of total students) in Hong Kong and Female students (as % of total students) in Poland?
Keep it short and to the point. -20.57. In the year 2007, what is the difference between the Female students (as % of total students) of Small states and Female students (as % of total students) of Costa Rica?
Keep it short and to the point. -10.56. In the year 2007, what is the difference between the Female students (as % of total students) of Small states and Female students (as % of total students) of Hong Kong?
Your answer should be compact. 24.91. In the year 2007, what is the difference between the Female students (as % of total students) in Small states and Female students (as % of total students) in Poland?
Your answer should be compact. 3.8. In the year 2007, what is the difference between the Female students (as % of total students) in Costa Rica and Female students (as % of total students) in Hong Kong?
Give a very brief answer. 35.48. In the year 2007, what is the difference between the Female students (as % of total students) in Costa Rica and Female students (as % of total students) in Poland?
Provide a succinct answer. 14.36. In the year 2007, what is the difference between the Female students (as % of total students) of Hong Kong and Female students (as % of total students) of Poland?
Your answer should be very brief. -21.12. In the year 2008, what is the difference between the Female students (as % of total students) of Small states and Female students (as % of total students) of Costa Rica?
Provide a short and direct response. -9.1. In the year 2008, what is the difference between the Female students (as % of total students) of Small states and Female students (as % of total students) of Hong Kong?
Your answer should be compact. 31.56. In the year 2008, what is the difference between the Female students (as % of total students) in Small states and Female students (as % of total students) in Poland?
Provide a succinct answer. 5.02. In the year 2008, what is the difference between the Female students (as % of total students) in Costa Rica and Female students (as % of total students) in Hong Kong?
Offer a very short reply. 40.67. In the year 2008, what is the difference between the Female students (as % of total students) of Costa Rica and Female students (as % of total students) of Poland?
Ensure brevity in your answer.  14.13. In the year 2008, what is the difference between the Female students (as % of total students) in Hong Kong and Female students (as % of total students) in Poland?
Keep it short and to the point. -26.54. What is the ratio of the Female students (as % of total students) of Small states in 1996 to that in 2001?
Provide a succinct answer. 1.04. What is the ratio of the Female students (as % of total students) in Hong Kong in 1996 to that in 2001?
Ensure brevity in your answer.  3.07. What is the ratio of the Female students (as % of total students) in Poland in 1996 to that in 2001?
Your answer should be very brief. 1.02. What is the ratio of the Female students (as % of total students) of Small states in 1996 to that in 2002?
Your answer should be very brief. 1.01. What is the ratio of the Female students (as % of total students) in Costa Rica in 1996 to that in 2002?
Your response must be concise. 0.99. What is the ratio of the Female students (as % of total students) of Hong Kong in 1996 to that in 2002?
Give a very brief answer. 3.42. What is the ratio of the Female students (as % of total students) in Poland in 1996 to that in 2002?
Your answer should be very brief. 1.03. What is the ratio of the Female students (as % of total students) of Small states in 1996 to that in 2004?
Make the answer very short. 1.04. What is the ratio of the Female students (as % of total students) in Costa Rica in 1996 to that in 2004?
Ensure brevity in your answer.  0.97. What is the ratio of the Female students (as % of total students) of Hong Kong in 1996 to that in 2004?
Your answer should be very brief. 2.6. What is the ratio of the Female students (as % of total students) in Poland in 1996 to that in 2004?
Offer a terse response. 1.03. What is the ratio of the Female students (as % of total students) of Small states in 1996 to that in 2005?
Provide a short and direct response. 1.04. What is the ratio of the Female students (as % of total students) of Costa Rica in 1996 to that in 2005?
Make the answer very short. 0.97. What is the ratio of the Female students (as % of total students) in Hong Kong in 1996 to that in 2005?
Provide a short and direct response. 2.17. What is the ratio of the Female students (as % of total students) of Poland in 1996 to that in 2005?
Provide a short and direct response. 1.11. What is the ratio of the Female students (as % of total students) of Small states in 1996 to that in 2006?
Give a very brief answer. 1.06. What is the ratio of the Female students (as % of total students) of Costa Rica in 1996 to that in 2006?
Provide a short and direct response. 0.98. What is the ratio of the Female students (as % of total students) of Hong Kong in 1996 to that in 2006?
Provide a succinct answer. 2.08. What is the ratio of the Female students (as % of total students) of Poland in 1996 to that in 2006?
Provide a succinct answer. 1.15. What is the ratio of the Female students (as % of total students) in Small states in 1996 to that in 2007?
Offer a terse response. 1.06. What is the ratio of the Female students (as % of total students) in Costa Rica in 1996 to that in 2007?
Make the answer very short. 0.97. What is the ratio of the Female students (as % of total students) in Hong Kong in 1996 to that in 2007?
Ensure brevity in your answer.  2.13. What is the ratio of the Female students (as % of total students) of Poland in 1996 to that in 2007?
Offer a very short reply. 1.14. What is the ratio of the Female students (as % of total students) in Small states in 1996 to that in 2008?
Your answer should be very brief. 1.02. What is the ratio of the Female students (as % of total students) in Costa Rica in 1996 to that in 2008?
Your answer should be compact. 0.97. What is the ratio of the Female students (as % of total students) of Hong Kong in 1996 to that in 2008?
Give a very brief answer. 3.19. What is the ratio of the Female students (as % of total students) in Poland in 1996 to that in 2008?
Make the answer very short. 1.13. What is the ratio of the Female students (as % of total students) of Small states in 2001 to that in 2002?
Give a very brief answer. 0.97. What is the ratio of the Female students (as % of total students) in Costa Rica in 2001 to that in 2002?
Offer a terse response. 0.98. What is the ratio of the Female students (as % of total students) of Hong Kong in 2001 to that in 2002?
Your response must be concise. 1.11. What is the ratio of the Female students (as % of total students) in Poland in 2001 to that in 2002?
Your response must be concise. 1.01. What is the ratio of the Female students (as % of total students) in Small states in 2001 to that in 2004?
Your response must be concise. 1. What is the ratio of the Female students (as % of total students) of Costa Rica in 2001 to that in 2004?
Give a very brief answer. 0.97. What is the ratio of the Female students (as % of total students) in Hong Kong in 2001 to that in 2004?
Keep it short and to the point. 0.85. What is the ratio of the Female students (as % of total students) of Poland in 2001 to that in 2004?
Make the answer very short. 1.01. What is the ratio of the Female students (as % of total students) of Costa Rica in 2001 to that in 2005?
Make the answer very short. 0.96. What is the ratio of the Female students (as % of total students) in Hong Kong in 2001 to that in 2005?
Provide a succinct answer. 0.71. What is the ratio of the Female students (as % of total students) of Poland in 2001 to that in 2005?
Offer a very short reply. 1.09. What is the ratio of the Female students (as % of total students) of Small states in 2001 to that in 2006?
Keep it short and to the point. 1.02. What is the ratio of the Female students (as % of total students) in Costa Rica in 2001 to that in 2006?
Provide a short and direct response. 0.97. What is the ratio of the Female students (as % of total students) in Hong Kong in 2001 to that in 2006?
Your response must be concise. 0.68. What is the ratio of the Female students (as % of total students) in Poland in 2001 to that in 2006?
Keep it short and to the point. 1.12. What is the ratio of the Female students (as % of total students) in Small states in 2001 to that in 2007?
Make the answer very short. 1.02. What is the ratio of the Female students (as % of total students) of Costa Rica in 2001 to that in 2007?
Ensure brevity in your answer.  0.97. What is the ratio of the Female students (as % of total students) of Hong Kong in 2001 to that in 2007?
Give a very brief answer. 0.69. What is the ratio of the Female students (as % of total students) of Poland in 2001 to that in 2007?
Keep it short and to the point. 1.12. What is the ratio of the Female students (as % of total students) of Small states in 2001 to that in 2008?
Your answer should be compact. 0.98. What is the ratio of the Female students (as % of total students) in Costa Rica in 2001 to that in 2008?
Ensure brevity in your answer.  0.97. What is the ratio of the Female students (as % of total students) in Hong Kong in 2001 to that in 2008?
Your answer should be very brief. 1.04. What is the ratio of the Female students (as % of total students) of Poland in 2001 to that in 2008?
Ensure brevity in your answer.  1.11. What is the ratio of the Female students (as % of total students) in Small states in 2002 to that in 2004?
Give a very brief answer. 1.03. What is the ratio of the Female students (as % of total students) in Costa Rica in 2002 to that in 2004?
Your response must be concise. 0.99. What is the ratio of the Female students (as % of total students) in Hong Kong in 2002 to that in 2004?
Keep it short and to the point. 0.76. What is the ratio of the Female students (as % of total students) of Small states in 2002 to that in 2005?
Offer a very short reply. 1.03. What is the ratio of the Female students (as % of total students) of Costa Rica in 2002 to that in 2005?
Your answer should be compact. 0.98. What is the ratio of the Female students (as % of total students) in Hong Kong in 2002 to that in 2005?
Ensure brevity in your answer.  0.63. What is the ratio of the Female students (as % of total students) in Poland in 2002 to that in 2005?
Offer a very short reply. 1.08. What is the ratio of the Female students (as % of total students) of Small states in 2002 to that in 2006?
Keep it short and to the point. 1.05. What is the ratio of the Female students (as % of total students) in Costa Rica in 2002 to that in 2006?
Your response must be concise. 0.99. What is the ratio of the Female students (as % of total students) of Hong Kong in 2002 to that in 2006?
Your answer should be very brief. 0.61. What is the ratio of the Female students (as % of total students) of Poland in 2002 to that in 2006?
Offer a terse response. 1.11. What is the ratio of the Female students (as % of total students) of Small states in 2002 to that in 2007?
Provide a succinct answer. 1.05. What is the ratio of the Female students (as % of total students) of Costa Rica in 2002 to that in 2007?
Offer a very short reply. 0.99. What is the ratio of the Female students (as % of total students) in Hong Kong in 2002 to that in 2007?
Keep it short and to the point. 0.62. What is the ratio of the Female students (as % of total students) of Poland in 2002 to that in 2007?
Keep it short and to the point. 1.11. What is the ratio of the Female students (as % of total students) of Small states in 2002 to that in 2008?
Your answer should be compact. 1.01. What is the ratio of the Female students (as % of total students) of Costa Rica in 2002 to that in 2008?
Offer a terse response. 0.98. What is the ratio of the Female students (as % of total students) of Hong Kong in 2002 to that in 2008?
Your response must be concise. 0.93. What is the ratio of the Female students (as % of total students) in Poland in 2002 to that in 2008?
Your answer should be compact. 1.1. What is the ratio of the Female students (as % of total students) in Hong Kong in 2004 to that in 2005?
Your answer should be compact. 0.83. What is the ratio of the Female students (as % of total students) of Poland in 2004 to that in 2005?
Offer a terse response. 1.08. What is the ratio of the Female students (as % of total students) of Small states in 2004 to that in 2006?
Your response must be concise. 1.02. What is the ratio of the Female students (as % of total students) in Costa Rica in 2004 to that in 2006?
Offer a terse response. 1. What is the ratio of the Female students (as % of total students) of Hong Kong in 2004 to that in 2006?
Keep it short and to the point. 0.8. What is the ratio of the Female students (as % of total students) of Poland in 2004 to that in 2006?
Provide a short and direct response. 1.11. What is the ratio of the Female students (as % of total students) in Small states in 2004 to that in 2007?
Offer a very short reply. 1.02. What is the ratio of the Female students (as % of total students) of Costa Rica in 2004 to that in 2007?
Keep it short and to the point. 1. What is the ratio of the Female students (as % of total students) in Hong Kong in 2004 to that in 2007?
Offer a very short reply. 0.82. What is the ratio of the Female students (as % of total students) in Poland in 2004 to that in 2007?
Give a very brief answer. 1.11. What is the ratio of the Female students (as % of total students) of Small states in 2004 to that in 2008?
Your response must be concise. 0.98. What is the ratio of the Female students (as % of total students) of Hong Kong in 2004 to that in 2008?
Provide a succinct answer. 1.23. What is the ratio of the Female students (as % of total students) in Poland in 2004 to that in 2008?
Provide a succinct answer. 1.1. What is the ratio of the Female students (as % of total students) of Small states in 2005 to that in 2006?
Provide a short and direct response. 1.02. What is the ratio of the Female students (as % of total students) of Costa Rica in 2005 to that in 2006?
Your response must be concise. 1.01. What is the ratio of the Female students (as % of total students) of Hong Kong in 2005 to that in 2006?
Your response must be concise. 0.96. What is the ratio of the Female students (as % of total students) in Poland in 2005 to that in 2006?
Provide a short and direct response. 1.03. What is the ratio of the Female students (as % of total students) in Small states in 2005 to that in 2007?
Your response must be concise. 1.02. What is the ratio of the Female students (as % of total students) in Hong Kong in 2005 to that in 2007?
Your answer should be compact. 0.98. What is the ratio of the Female students (as % of total students) of Poland in 2005 to that in 2007?
Offer a terse response. 1.03. What is the ratio of the Female students (as % of total students) of Small states in 2005 to that in 2008?
Give a very brief answer. 0.98. What is the ratio of the Female students (as % of total students) of Costa Rica in 2005 to that in 2008?
Make the answer very short. 1. What is the ratio of the Female students (as % of total students) in Hong Kong in 2005 to that in 2008?
Provide a succinct answer. 1.47. What is the ratio of the Female students (as % of total students) in Poland in 2005 to that in 2008?
Your answer should be compact. 1.02. What is the ratio of the Female students (as % of total students) of Hong Kong in 2006 to that in 2007?
Keep it short and to the point. 1.03. What is the ratio of the Female students (as % of total students) in Small states in 2006 to that in 2008?
Keep it short and to the point. 0.96. What is the ratio of the Female students (as % of total students) in Hong Kong in 2006 to that in 2008?
Keep it short and to the point. 1.54. What is the ratio of the Female students (as % of total students) of Poland in 2006 to that in 2008?
Offer a very short reply. 0.98. What is the ratio of the Female students (as % of total students) of Small states in 2007 to that in 2008?
Provide a short and direct response. 0.96. What is the ratio of the Female students (as % of total students) of Hong Kong in 2007 to that in 2008?
Your answer should be very brief. 1.5. What is the ratio of the Female students (as % of total students) in Poland in 2007 to that in 2008?
Ensure brevity in your answer.  0.99. What is the difference between the highest and the second highest Female students (as % of total students) in Small states?
Keep it short and to the point. 0.36. What is the difference between the highest and the second highest Female students (as % of total students) in Costa Rica?
Provide a short and direct response. 0.17. What is the difference between the highest and the second highest Female students (as % of total students) of Hong Kong?
Your answer should be compact. 16.6. What is the difference between the highest and the second highest Female students (as % of total students) of Poland?
Give a very brief answer. 0.89. What is the difference between the highest and the lowest Female students (as % of total students) of Small states?
Your answer should be very brief. 2.47. What is the difference between the highest and the lowest Female students (as % of total students) in Costa Rica?
Provide a succinct answer. 1.91. What is the difference between the highest and the lowest Female students (as % of total students) of Hong Kong?
Make the answer very short. 22.65. What is the difference between the highest and the lowest Female students (as % of total students) in Poland?
Offer a terse response. 5.37. 